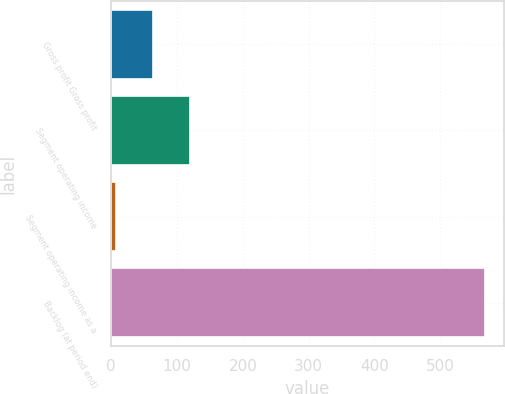Convert chart. <chart><loc_0><loc_0><loc_500><loc_500><bar_chart><fcel>Gross profit Gross profit<fcel>Segment operating income<fcel>Segment operating income as a<fcel>Backlog (at period end)<nl><fcel>63.26<fcel>119.32<fcel>7.2<fcel>567.8<nl></chart> 